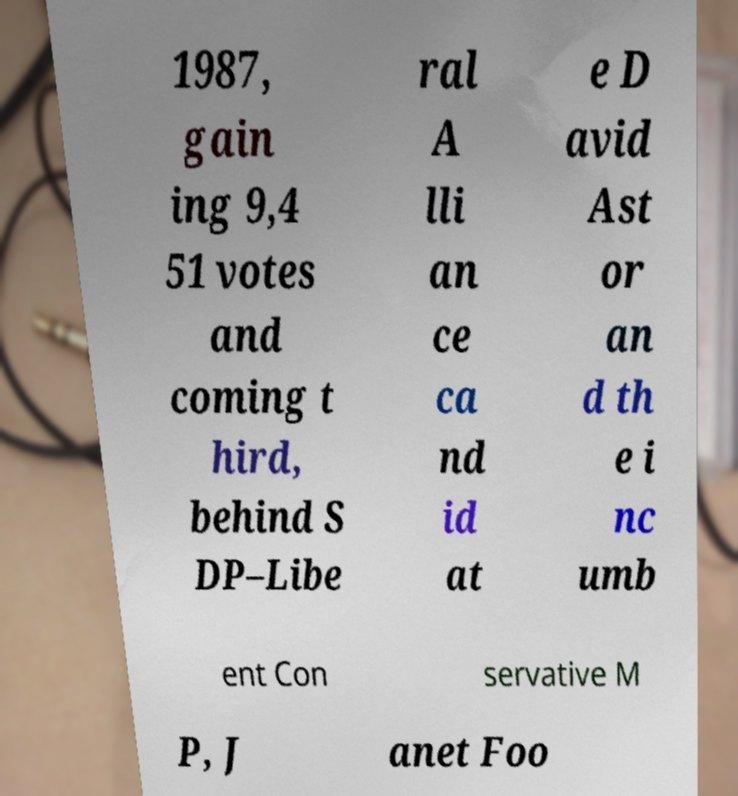I need the written content from this picture converted into text. Can you do that? 1987, gain ing 9,4 51 votes and coming t hird, behind S DP–Libe ral A lli an ce ca nd id at e D avid Ast or an d th e i nc umb ent Con servative M P, J anet Foo 